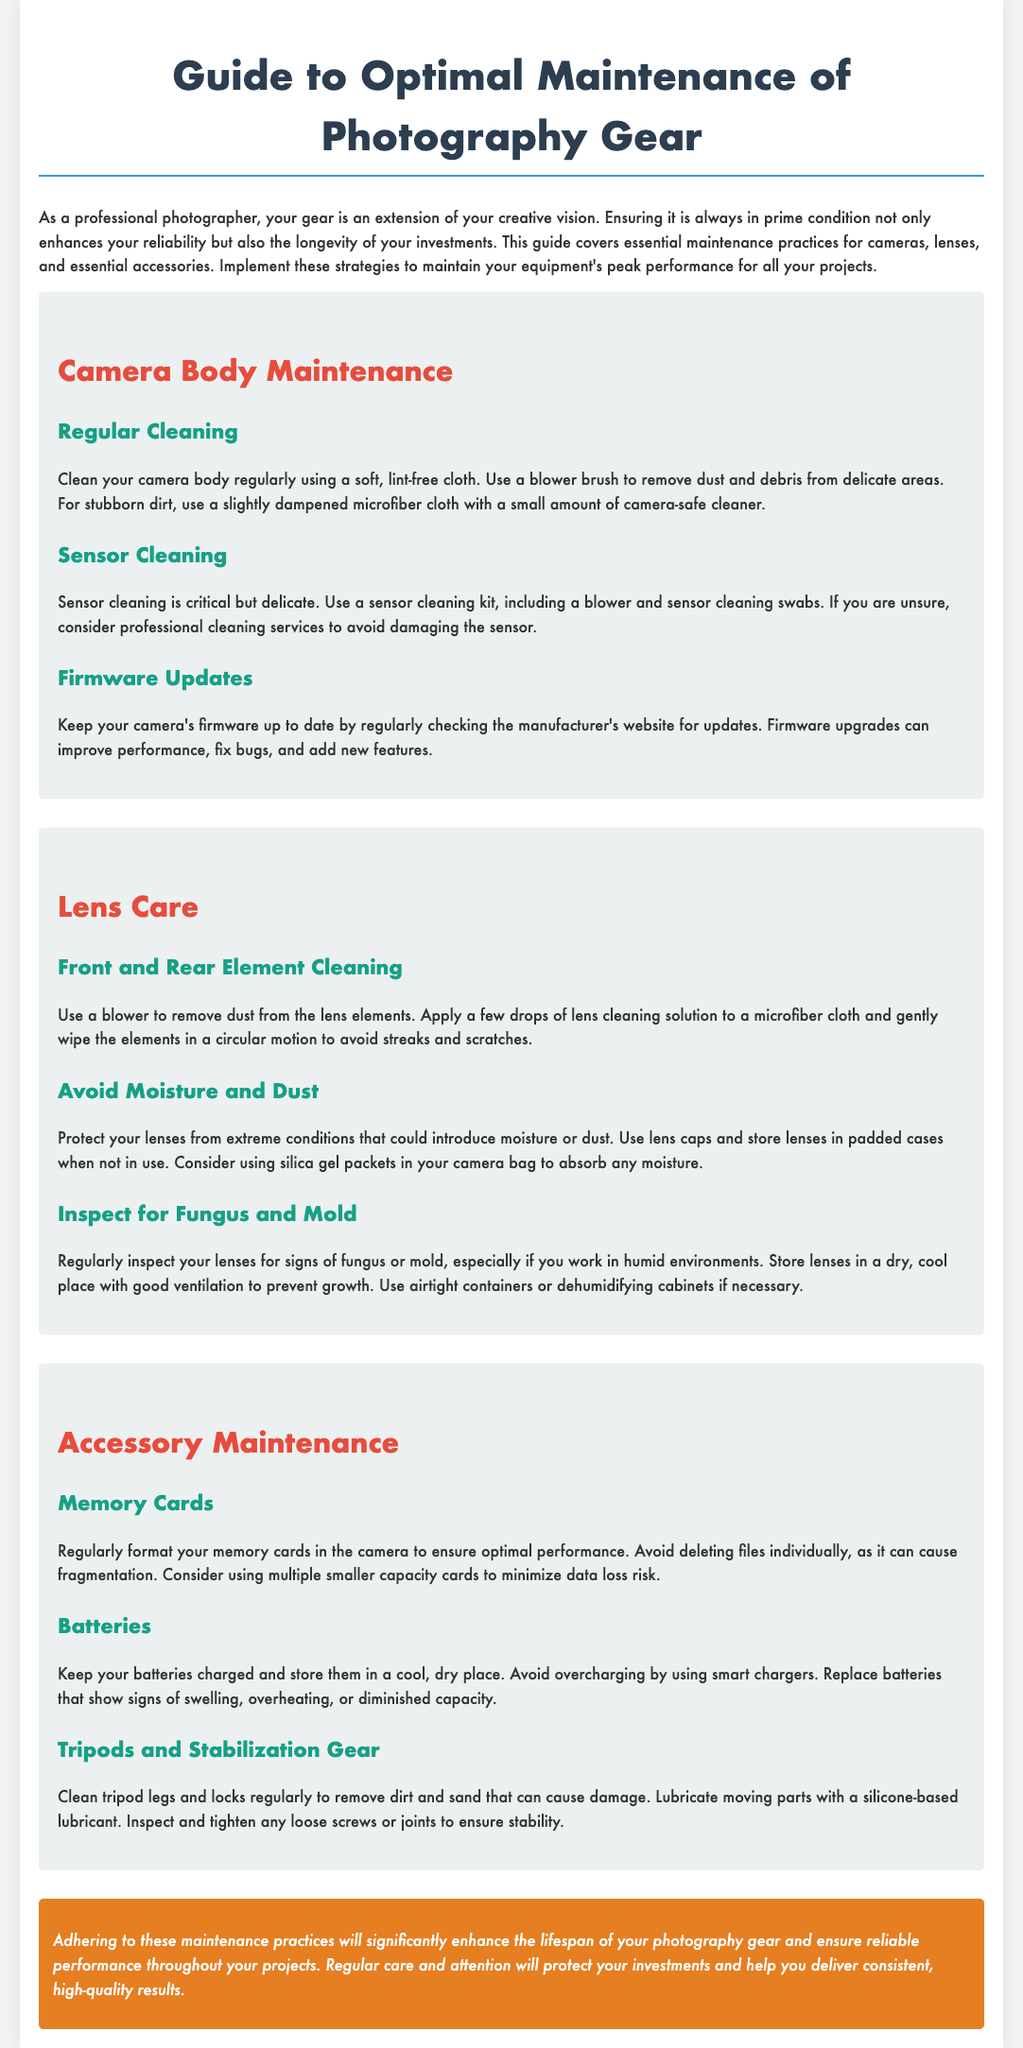What is the main purpose of the guide? The guide covers essential maintenance practices for cameras, lenses, and essential accessories to ensure longevity and peak performance.
Answer: To ensure longevity and peak performance How often should you clean the camera body? The document suggests cleaning the camera body regularly.
Answer: Regularly What should you use for stubborn dirt on the camera body? For stubborn dirt, use a slightly dampened microfiber cloth with a small amount of camera-safe cleaner.
Answer: A slightly dampened microfiber cloth What is recommended for moisture protection of lenses? Use lens caps and store lenses in padded cases when not in use.
Answer: Lens caps and padded cases How should memory cards be formatted? Regularly format your memory cards in the camera to ensure optimal performance.
Answer: In the camera What is critical for sensor cleaning? Sensor cleaning is critical but delicate, and using a proper sensor cleaning kit is essential.
Answer: Proper sensor cleaning kit What should you do with batteries that show signs of swelling? Replace batteries that show signs of swelling, overheating, or diminished capacity.
Answer: Replace them What type of lubricant is recommended for tripods? Use a silicone-based lubricant to lubricate moving parts.
Answer: Silicone-based lubricant How are lens elements cleaned? Apply a few drops of lens cleaning solution to a microfiber cloth and gently wipe the elements in a circular motion.
Answer: Microfiber cloth and lens cleaning solution 